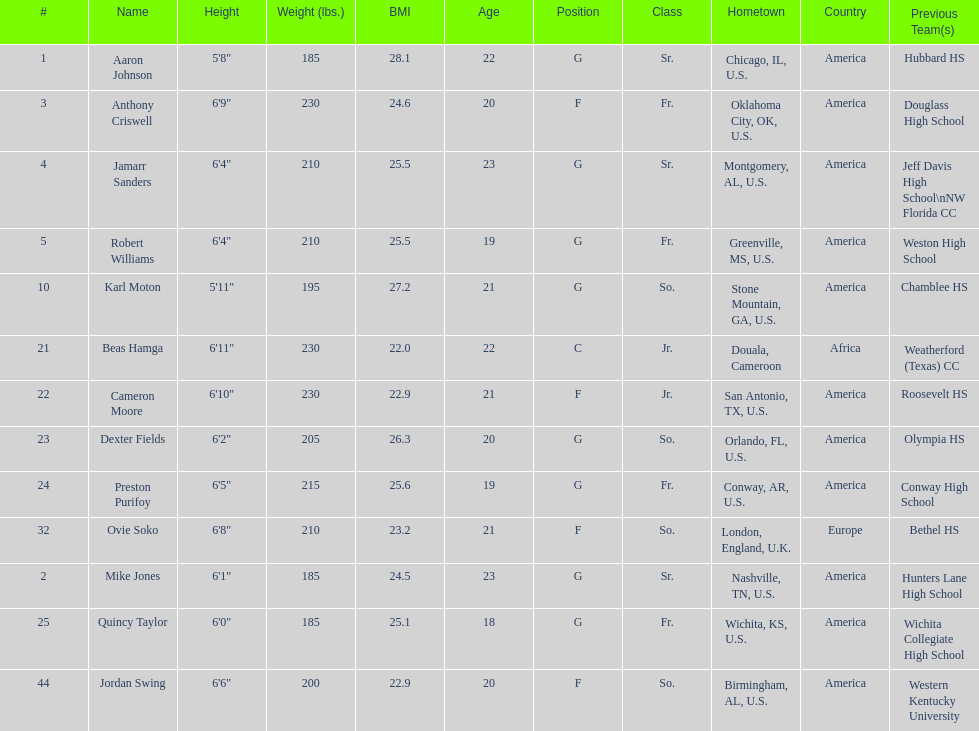How many players come from alabama? 2. 